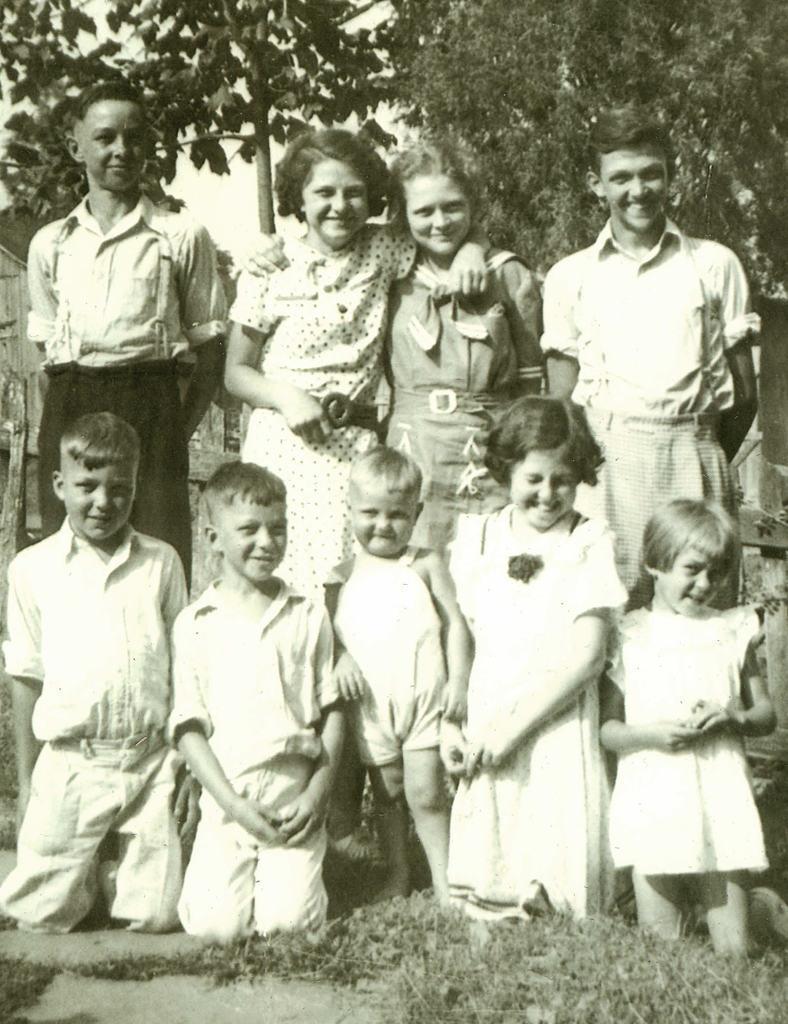How would you summarize this image in a sentence or two? As we can see in the image there is grass, group of people in the front and in the background there are trees. 